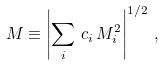<formula> <loc_0><loc_0><loc_500><loc_500>M \equiv \left | \sum _ { i } \, c _ { i } \, M _ { i } ^ { 2 } \right | ^ { 1 / 2 } \, ,</formula> 